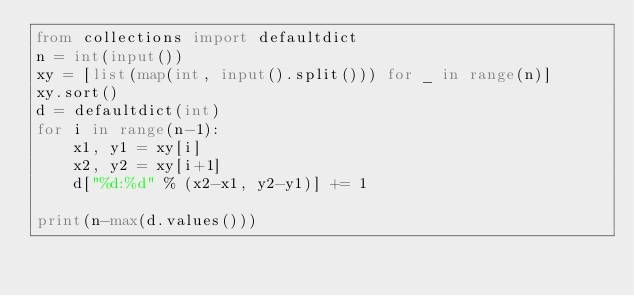<code> <loc_0><loc_0><loc_500><loc_500><_Python_>from collections import defaultdict
n = int(input())
xy = [list(map(int, input().split())) for _ in range(n)]
xy.sort()
d = defaultdict(int)
for i in range(n-1):
    x1, y1 = xy[i]
    x2, y2 = xy[i+1]
    d["%d:%d" % (x2-x1, y2-y1)] += 1

print(n-max(d.values()))
</code> 